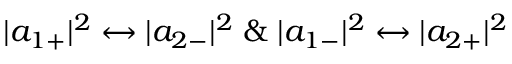<formula> <loc_0><loc_0><loc_500><loc_500>| a _ { 1 + } | ^ { 2 } \leftrightarrow | a _ { 2 - } | ^ { 2 } \, \& \, | a _ { 1 - } | ^ { 2 } \leftrightarrow | a _ { 2 + } | ^ { 2 }</formula> 